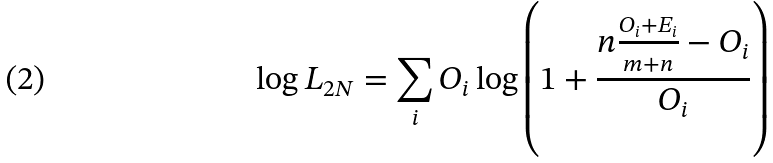<formula> <loc_0><loc_0><loc_500><loc_500>\log { L _ { 2 N } } = \sum _ { i } O _ { i } \log { \left ( 1 + \frac { n \frac { O _ { i } + E _ { i } } { m + n } - O _ { i } } { O _ { i } } \right ) }</formula> 